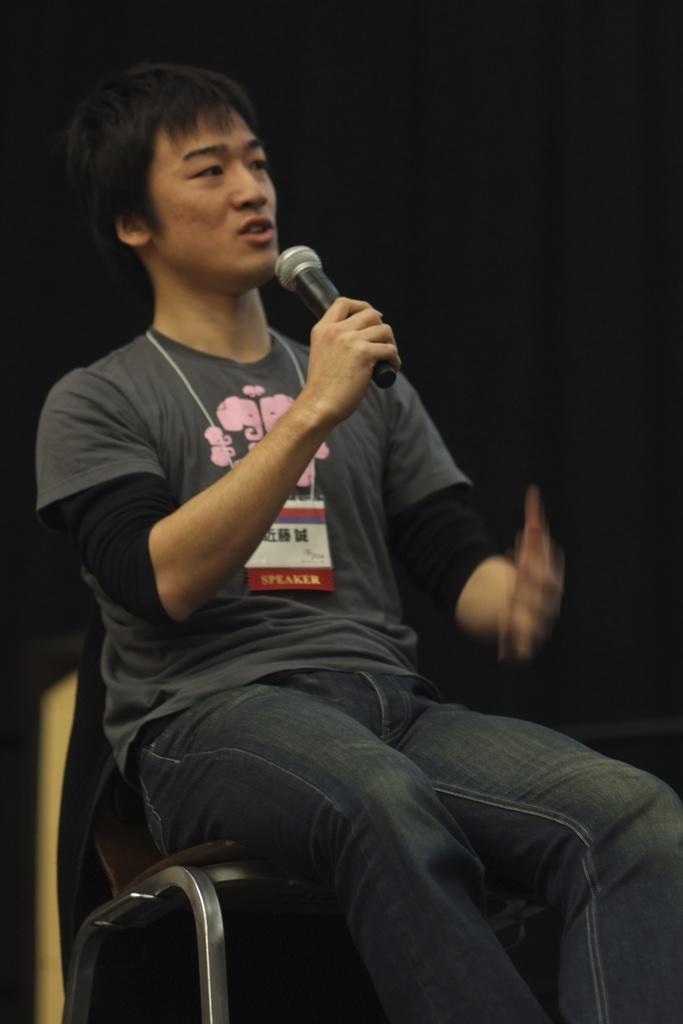Who is the person in the image? There is a man in the image. What is the man doing in the image? The man is sitting on a chair and speaking. What is the man holding in his right hand? The man is holding a microphone in his right hand. What type of bit is the man using to control the horse in the image? There is no horse or bit present in the image; it features a man sitting on a chair and holding a microphone. 